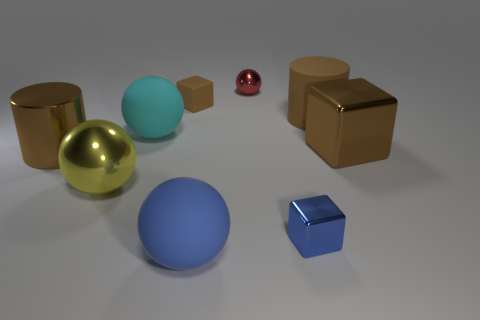The big thing that is the same shape as the small blue shiny thing is what color?
Offer a very short reply. Brown. Is the material of the cyan sphere that is to the right of the large shiny ball the same as the yellow thing?
Offer a very short reply. No. The shiny cylinder that is the same color as the big matte cylinder is what size?
Keep it short and to the point. Large. How many cyan balls are the same size as the yellow metal sphere?
Ensure brevity in your answer.  1. Are there an equal number of big yellow objects that are to the right of the small blue thing and tiny brown blocks?
Your answer should be compact. No. How many things are both on the right side of the big brown matte thing and behind the tiny brown rubber thing?
Offer a terse response. 0. What size is the brown block that is the same material as the blue cube?
Your response must be concise. Large. How many large cyan objects are the same shape as the tiny brown matte thing?
Provide a short and direct response. 0. Are there more objects in front of the big cube than brown shiny objects?
Keep it short and to the point. Yes. There is a shiny thing that is on the right side of the brown metal cylinder and on the left side of the small rubber block; what is its shape?
Your answer should be compact. Sphere. 